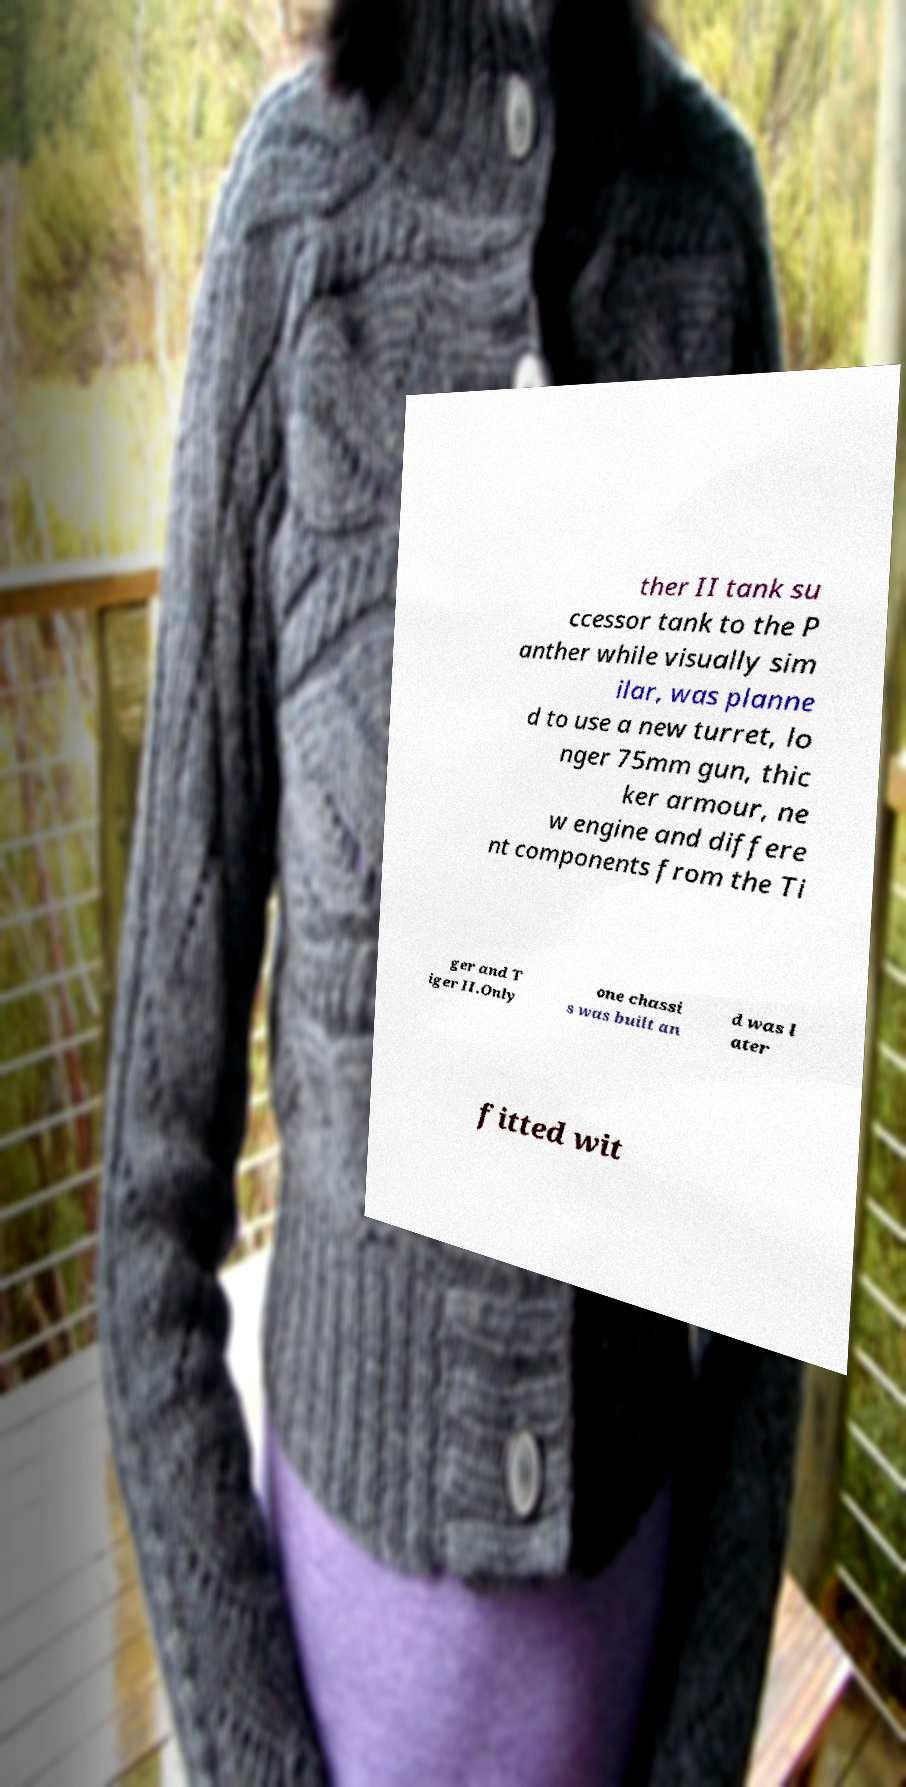Could you extract and type out the text from this image? ther II tank su ccessor tank to the P anther while visually sim ilar, was planne d to use a new turret, lo nger 75mm gun, thic ker armour, ne w engine and differe nt components from the Ti ger and T iger II.Only one chassi s was built an d was l ater fitted wit 